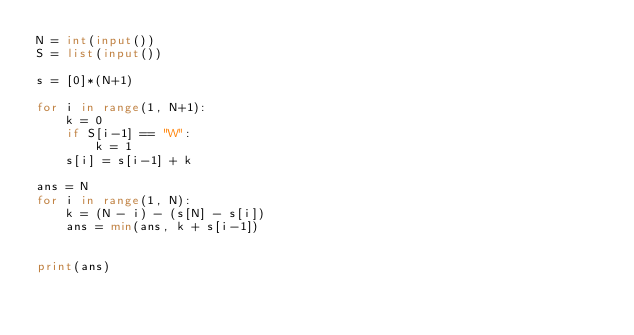<code> <loc_0><loc_0><loc_500><loc_500><_Python_>N = int(input())
S = list(input())

s = [0]*(N+1)

for i in range(1, N+1):
    k = 0
    if S[i-1] == "W":
        k = 1
    s[i] = s[i-1] + k

ans = N
for i in range(1, N):
    k = (N - i) - (s[N] - s[i])
    ans = min(ans, k + s[i-1])


print(ans)
</code> 